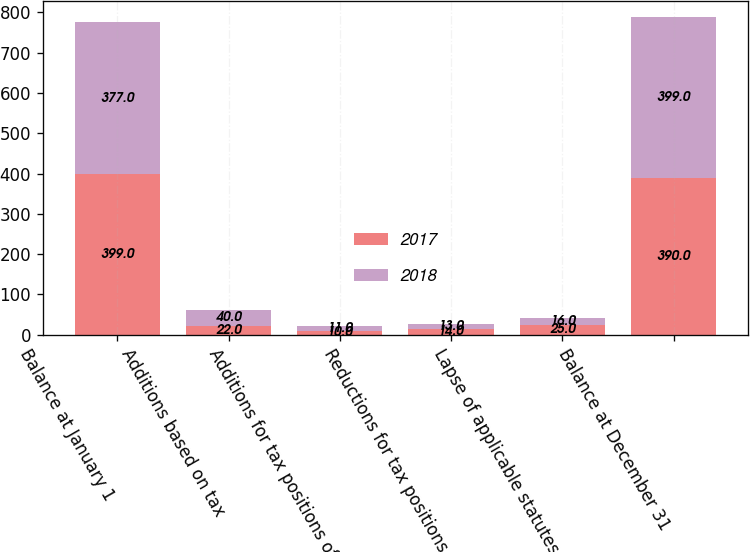Convert chart. <chart><loc_0><loc_0><loc_500><loc_500><stacked_bar_chart><ecel><fcel>Balance at January 1<fcel>Additions based on tax<fcel>Additions for tax positions of<fcel>Reductions for tax positions<fcel>Lapse of applicable statutes<fcel>Balance at December 31<nl><fcel>2017<fcel>399<fcel>22<fcel>10<fcel>14<fcel>25<fcel>390<nl><fcel>2018<fcel>377<fcel>40<fcel>11<fcel>13<fcel>16<fcel>399<nl></chart> 